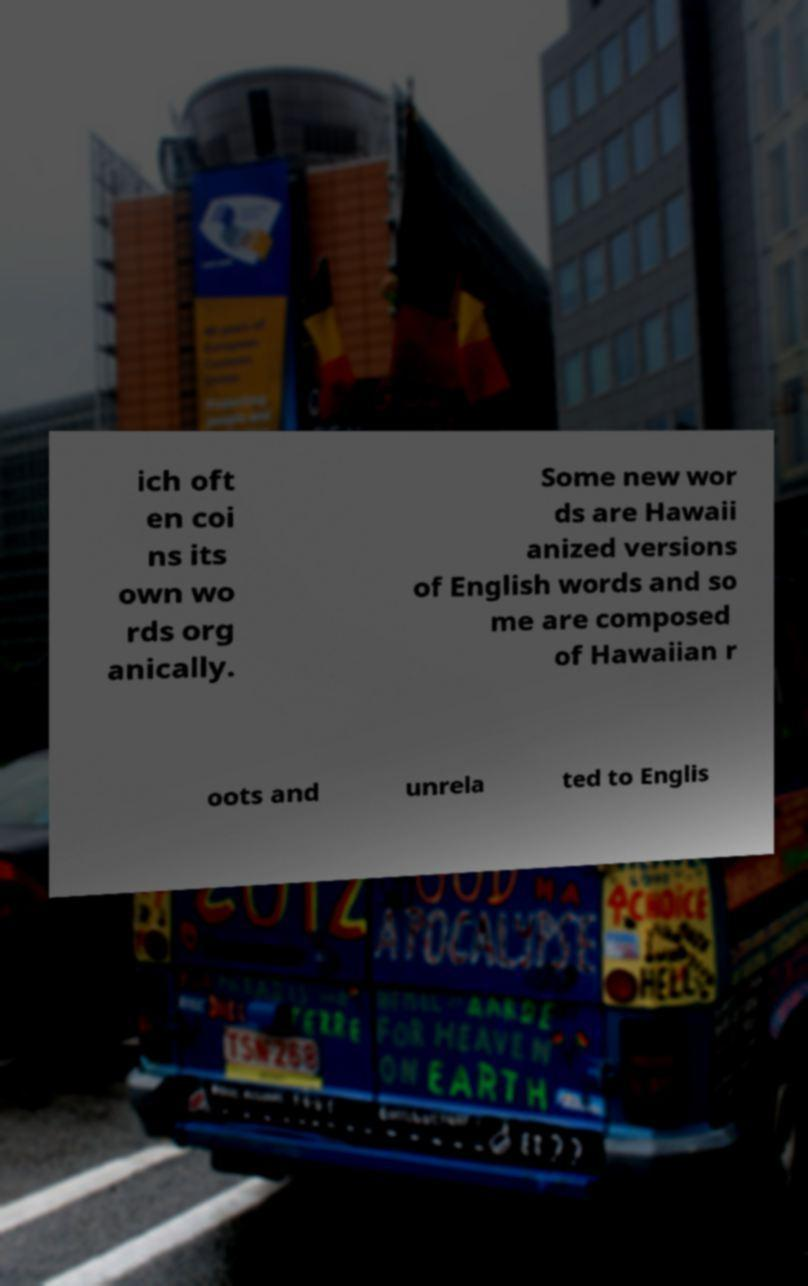Can you accurately transcribe the text from the provided image for me? ich oft en coi ns its own wo rds org anically. Some new wor ds are Hawaii anized versions of English words and so me are composed of Hawaiian r oots and unrela ted to Englis 